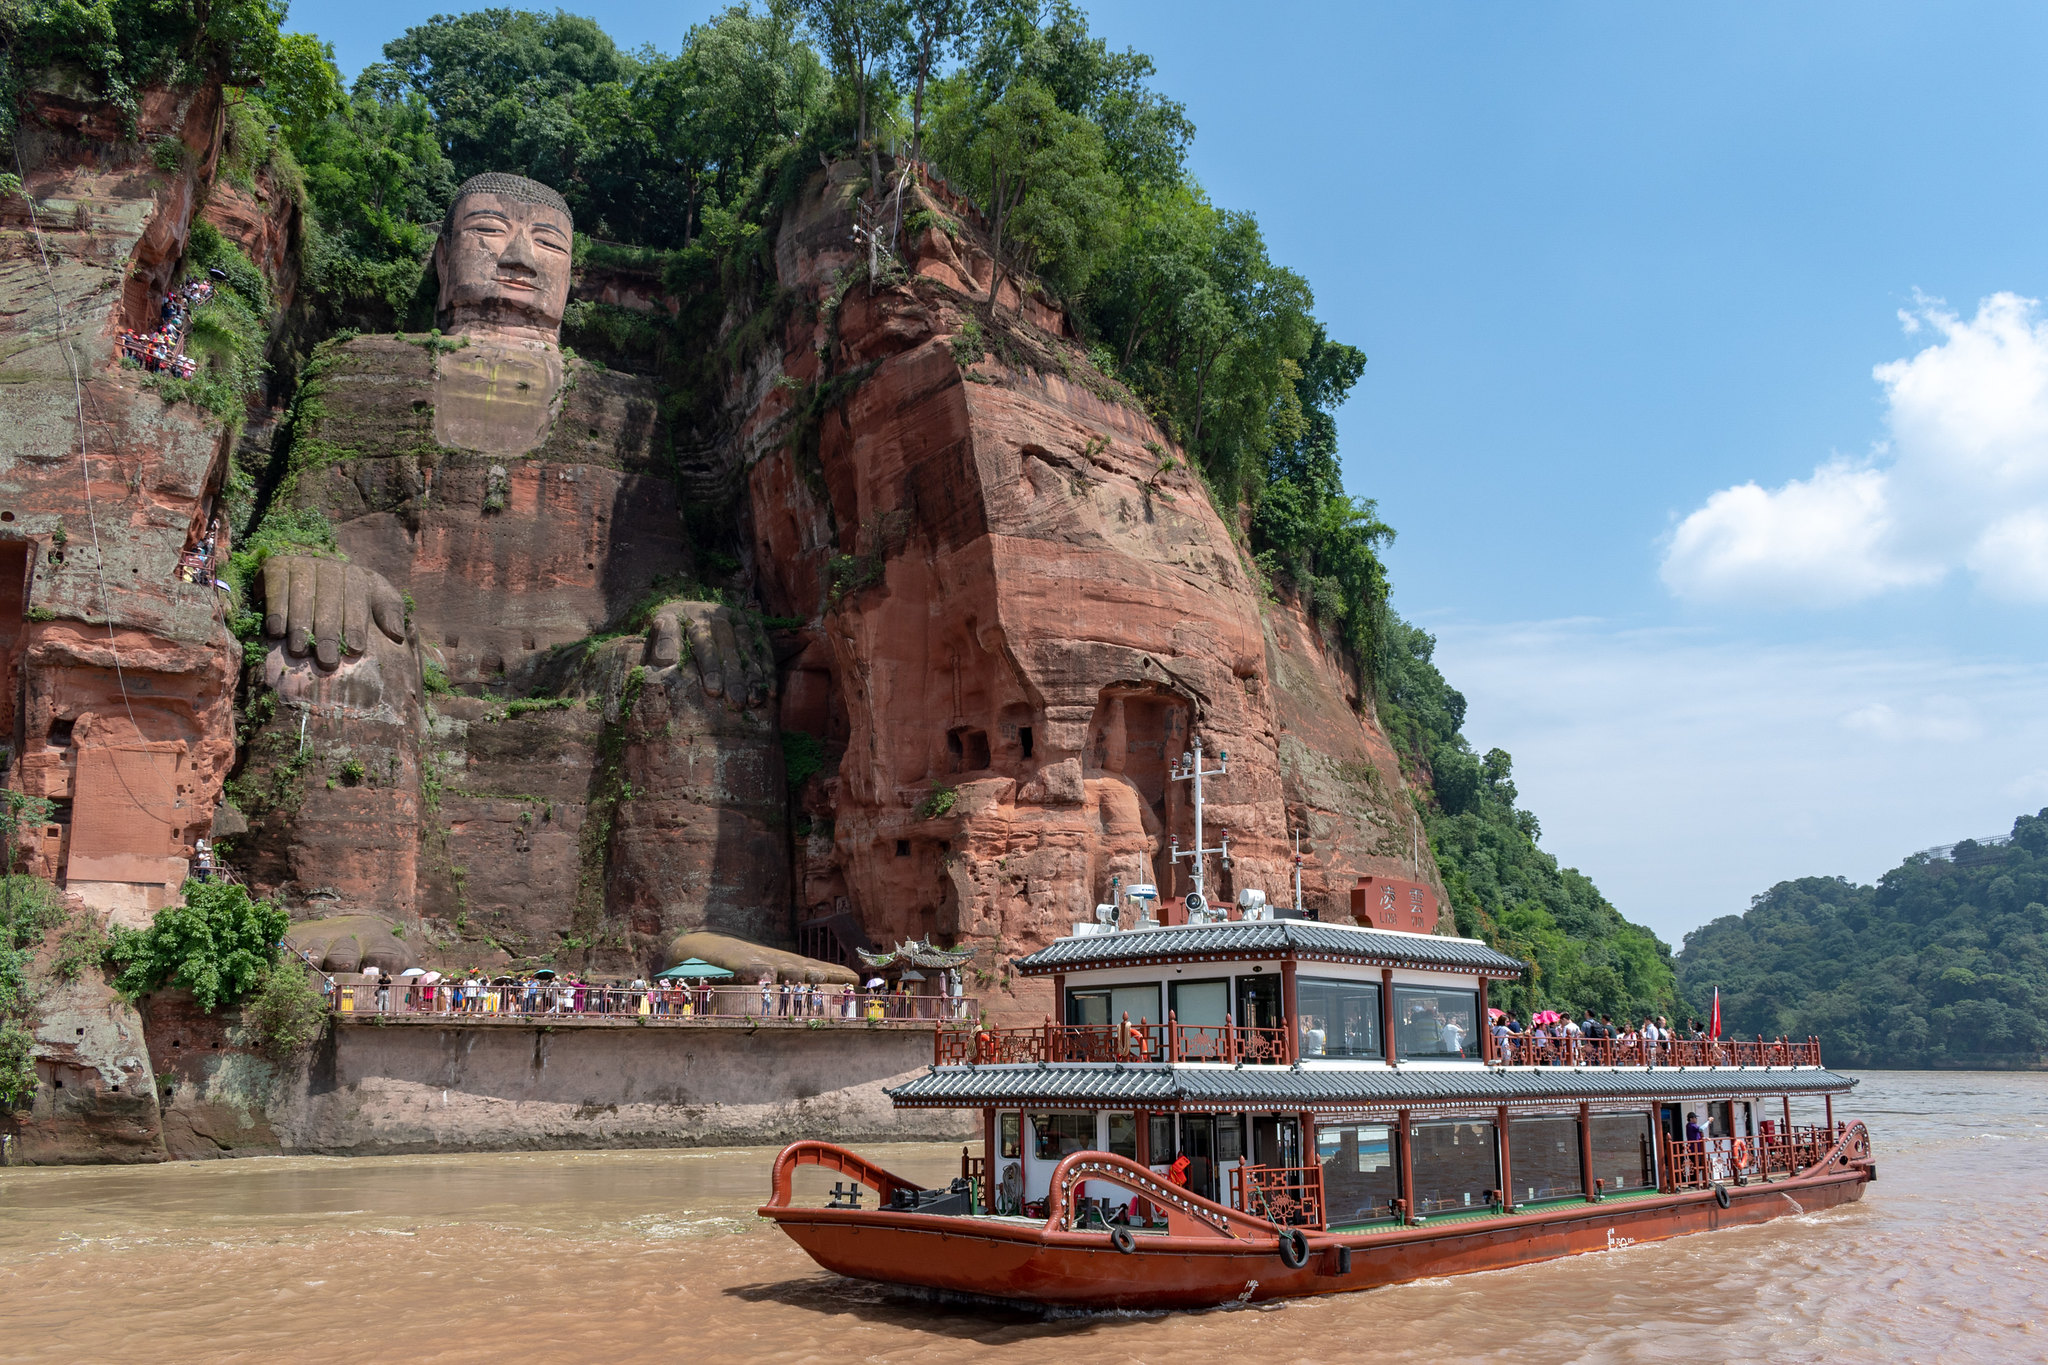What are the key elements in this picture? The image prominently features the awe-inspiring Leshan Giant Buddha, a massive stone statue carved into the cliffs of Sichuan, China. Standing at 71 meters tall, this colossal figure is recognized as the world’s largest stone Buddha. The vantage point of the photo, taken from a boat on the river below, highlights the statue’s imposing presence against the natural landscape. The boat itself, a traditional Chinese design adorned with red and white colors, adds cultural vibrancy to the scene. Meanwhile, the serene blue sky and lush green trees on the cliff provide a beautiful natural backdrop, creating a stunning contrast between human-made marvel and nature's beauty. 